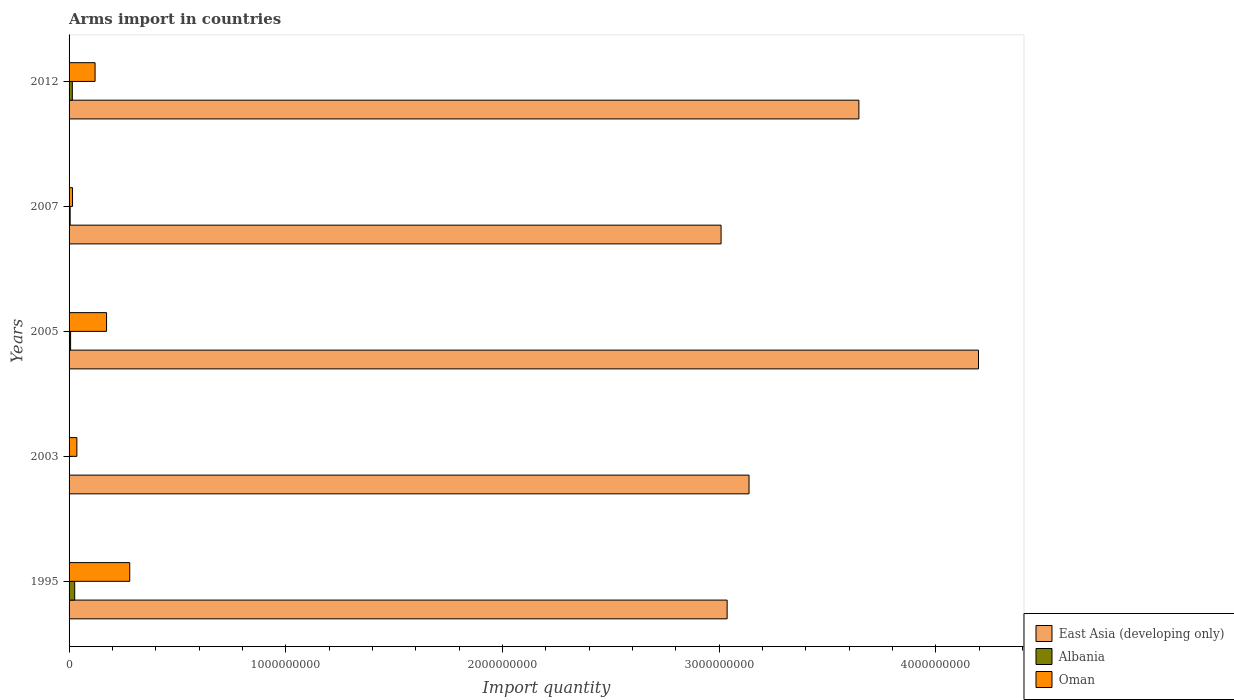How many groups of bars are there?
Provide a succinct answer. 5. Are the number of bars on each tick of the Y-axis equal?
Your answer should be compact. Yes. In how many cases, is the number of bars for a given year not equal to the number of legend labels?
Offer a very short reply. 0. What is the total arms import in Oman in 2003?
Offer a terse response. 3.60e+07. Across all years, what is the maximum total arms import in East Asia (developing only)?
Offer a very short reply. 4.20e+09. Across all years, what is the minimum total arms import in Oman?
Make the answer very short. 1.60e+07. In which year was the total arms import in Oman maximum?
Provide a short and direct response. 1995. In which year was the total arms import in Albania minimum?
Your answer should be compact. 2003. What is the total total arms import in Oman in the graph?
Keep it short and to the point. 6.25e+08. What is the difference between the total arms import in Oman in 1995 and that in 2003?
Provide a short and direct response. 2.44e+08. What is the difference between the total arms import in Oman in 2005 and the total arms import in East Asia (developing only) in 2003?
Your response must be concise. -2.96e+09. What is the average total arms import in East Asia (developing only) per year?
Provide a succinct answer. 3.41e+09. In the year 2012, what is the difference between the total arms import in East Asia (developing only) and total arms import in Albania?
Offer a very short reply. 3.63e+09. In how many years, is the total arms import in Albania greater than 1400000000 ?
Ensure brevity in your answer.  0. What is the ratio of the total arms import in East Asia (developing only) in 1995 to that in 2012?
Keep it short and to the point. 0.83. Is the total arms import in East Asia (developing only) in 2003 less than that in 2005?
Your response must be concise. Yes. Is the difference between the total arms import in East Asia (developing only) in 1995 and 2007 greater than the difference between the total arms import in Albania in 1995 and 2007?
Your answer should be very brief. Yes. What is the difference between the highest and the second highest total arms import in Albania?
Keep it short and to the point. 1.10e+07. What is the difference between the highest and the lowest total arms import in Oman?
Give a very brief answer. 2.64e+08. In how many years, is the total arms import in East Asia (developing only) greater than the average total arms import in East Asia (developing only) taken over all years?
Ensure brevity in your answer.  2. Is the sum of the total arms import in East Asia (developing only) in 1995 and 2005 greater than the maximum total arms import in Albania across all years?
Your answer should be very brief. Yes. What does the 2nd bar from the top in 1995 represents?
Keep it short and to the point. Albania. What does the 3rd bar from the bottom in 1995 represents?
Your answer should be compact. Oman. Is it the case that in every year, the sum of the total arms import in East Asia (developing only) and total arms import in Oman is greater than the total arms import in Albania?
Your answer should be very brief. Yes. How many bars are there?
Your answer should be very brief. 15. Are all the bars in the graph horizontal?
Make the answer very short. Yes. Does the graph contain any zero values?
Make the answer very short. No. Does the graph contain grids?
Your answer should be compact. No. Where does the legend appear in the graph?
Provide a short and direct response. Bottom right. What is the title of the graph?
Offer a terse response. Arms import in countries. What is the label or title of the X-axis?
Give a very brief answer. Import quantity. What is the Import quantity in East Asia (developing only) in 1995?
Ensure brevity in your answer.  3.04e+09. What is the Import quantity of Albania in 1995?
Offer a terse response. 2.60e+07. What is the Import quantity in Oman in 1995?
Your response must be concise. 2.80e+08. What is the Import quantity of East Asia (developing only) in 2003?
Keep it short and to the point. 3.14e+09. What is the Import quantity of Oman in 2003?
Provide a short and direct response. 3.60e+07. What is the Import quantity in East Asia (developing only) in 2005?
Offer a very short reply. 4.20e+09. What is the Import quantity of Albania in 2005?
Provide a short and direct response. 7.00e+06. What is the Import quantity of Oman in 2005?
Make the answer very short. 1.73e+08. What is the Import quantity in East Asia (developing only) in 2007?
Keep it short and to the point. 3.01e+09. What is the Import quantity of Albania in 2007?
Your answer should be very brief. 5.00e+06. What is the Import quantity in Oman in 2007?
Offer a terse response. 1.60e+07. What is the Import quantity in East Asia (developing only) in 2012?
Ensure brevity in your answer.  3.64e+09. What is the Import quantity in Albania in 2012?
Your answer should be very brief. 1.50e+07. What is the Import quantity of Oman in 2012?
Give a very brief answer. 1.20e+08. Across all years, what is the maximum Import quantity in East Asia (developing only)?
Provide a short and direct response. 4.20e+09. Across all years, what is the maximum Import quantity of Albania?
Ensure brevity in your answer.  2.60e+07. Across all years, what is the maximum Import quantity of Oman?
Offer a very short reply. 2.80e+08. Across all years, what is the minimum Import quantity of East Asia (developing only)?
Your answer should be compact. 3.01e+09. Across all years, what is the minimum Import quantity of Oman?
Your answer should be very brief. 1.60e+07. What is the total Import quantity in East Asia (developing only) in the graph?
Make the answer very short. 1.70e+1. What is the total Import quantity in Albania in the graph?
Offer a very short reply. 5.50e+07. What is the total Import quantity in Oman in the graph?
Provide a succinct answer. 6.25e+08. What is the difference between the Import quantity in East Asia (developing only) in 1995 and that in 2003?
Keep it short and to the point. -1.01e+08. What is the difference between the Import quantity of Albania in 1995 and that in 2003?
Ensure brevity in your answer.  2.40e+07. What is the difference between the Import quantity of Oman in 1995 and that in 2003?
Ensure brevity in your answer.  2.44e+08. What is the difference between the Import quantity in East Asia (developing only) in 1995 and that in 2005?
Give a very brief answer. -1.16e+09. What is the difference between the Import quantity in Albania in 1995 and that in 2005?
Provide a succinct answer. 1.90e+07. What is the difference between the Import quantity of Oman in 1995 and that in 2005?
Provide a short and direct response. 1.07e+08. What is the difference between the Import quantity in East Asia (developing only) in 1995 and that in 2007?
Keep it short and to the point. 2.80e+07. What is the difference between the Import quantity of Albania in 1995 and that in 2007?
Ensure brevity in your answer.  2.10e+07. What is the difference between the Import quantity of Oman in 1995 and that in 2007?
Your answer should be compact. 2.64e+08. What is the difference between the Import quantity in East Asia (developing only) in 1995 and that in 2012?
Make the answer very short. -6.08e+08. What is the difference between the Import quantity in Albania in 1995 and that in 2012?
Your answer should be very brief. 1.10e+07. What is the difference between the Import quantity of Oman in 1995 and that in 2012?
Give a very brief answer. 1.60e+08. What is the difference between the Import quantity in East Asia (developing only) in 2003 and that in 2005?
Your response must be concise. -1.06e+09. What is the difference between the Import quantity of Albania in 2003 and that in 2005?
Offer a very short reply. -5.00e+06. What is the difference between the Import quantity of Oman in 2003 and that in 2005?
Provide a succinct answer. -1.37e+08. What is the difference between the Import quantity in East Asia (developing only) in 2003 and that in 2007?
Offer a very short reply. 1.29e+08. What is the difference between the Import quantity in Albania in 2003 and that in 2007?
Ensure brevity in your answer.  -3.00e+06. What is the difference between the Import quantity of Oman in 2003 and that in 2007?
Give a very brief answer. 2.00e+07. What is the difference between the Import quantity in East Asia (developing only) in 2003 and that in 2012?
Give a very brief answer. -5.07e+08. What is the difference between the Import quantity in Albania in 2003 and that in 2012?
Provide a succinct answer. -1.30e+07. What is the difference between the Import quantity in Oman in 2003 and that in 2012?
Provide a succinct answer. -8.40e+07. What is the difference between the Import quantity in East Asia (developing only) in 2005 and that in 2007?
Ensure brevity in your answer.  1.19e+09. What is the difference between the Import quantity of Albania in 2005 and that in 2007?
Ensure brevity in your answer.  2.00e+06. What is the difference between the Import quantity of Oman in 2005 and that in 2007?
Provide a short and direct response. 1.57e+08. What is the difference between the Import quantity of East Asia (developing only) in 2005 and that in 2012?
Give a very brief answer. 5.52e+08. What is the difference between the Import quantity of Albania in 2005 and that in 2012?
Keep it short and to the point. -8.00e+06. What is the difference between the Import quantity of Oman in 2005 and that in 2012?
Make the answer very short. 5.30e+07. What is the difference between the Import quantity in East Asia (developing only) in 2007 and that in 2012?
Ensure brevity in your answer.  -6.36e+08. What is the difference between the Import quantity in Albania in 2007 and that in 2012?
Provide a short and direct response. -1.00e+07. What is the difference between the Import quantity of Oman in 2007 and that in 2012?
Offer a very short reply. -1.04e+08. What is the difference between the Import quantity in East Asia (developing only) in 1995 and the Import quantity in Albania in 2003?
Your answer should be very brief. 3.04e+09. What is the difference between the Import quantity of East Asia (developing only) in 1995 and the Import quantity of Oman in 2003?
Ensure brevity in your answer.  3.00e+09. What is the difference between the Import quantity in Albania in 1995 and the Import quantity in Oman in 2003?
Offer a terse response. -1.00e+07. What is the difference between the Import quantity of East Asia (developing only) in 1995 and the Import quantity of Albania in 2005?
Keep it short and to the point. 3.03e+09. What is the difference between the Import quantity in East Asia (developing only) in 1995 and the Import quantity in Oman in 2005?
Offer a very short reply. 2.86e+09. What is the difference between the Import quantity of Albania in 1995 and the Import quantity of Oman in 2005?
Ensure brevity in your answer.  -1.47e+08. What is the difference between the Import quantity of East Asia (developing only) in 1995 and the Import quantity of Albania in 2007?
Make the answer very short. 3.03e+09. What is the difference between the Import quantity of East Asia (developing only) in 1995 and the Import quantity of Oman in 2007?
Make the answer very short. 3.02e+09. What is the difference between the Import quantity of East Asia (developing only) in 1995 and the Import quantity of Albania in 2012?
Provide a succinct answer. 3.02e+09. What is the difference between the Import quantity in East Asia (developing only) in 1995 and the Import quantity in Oman in 2012?
Provide a short and direct response. 2.92e+09. What is the difference between the Import quantity in Albania in 1995 and the Import quantity in Oman in 2012?
Keep it short and to the point. -9.40e+07. What is the difference between the Import quantity of East Asia (developing only) in 2003 and the Import quantity of Albania in 2005?
Provide a succinct answer. 3.13e+09. What is the difference between the Import quantity of East Asia (developing only) in 2003 and the Import quantity of Oman in 2005?
Give a very brief answer. 2.96e+09. What is the difference between the Import quantity in Albania in 2003 and the Import quantity in Oman in 2005?
Make the answer very short. -1.71e+08. What is the difference between the Import quantity of East Asia (developing only) in 2003 and the Import quantity of Albania in 2007?
Offer a very short reply. 3.13e+09. What is the difference between the Import quantity of East Asia (developing only) in 2003 and the Import quantity of Oman in 2007?
Your response must be concise. 3.12e+09. What is the difference between the Import quantity of Albania in 2003 and the Import quantity of Oman in 2007?
Provide a short and direct response. -1.40e+07. What is the difference between the Import quantity in East Asia (developing only) in 2003 and the Import quantity in Albania in 2012?
Your answer should be compact. 3.12e+09. What is the difference between the Import quantity of East Asia (developing only) in 2003 and the Import quantity of Oman in 2012?
Provide a succinct answer. 3.02e+09. What is the difference between the Import quantity of Albania in 2003 and the Import quantity of Oman in 2012?
Ensure brevity in your answer.  -1.18e+08. What is the difference between the Import quantity in East Asia (developing only) in 2005 and the Import quantity in Albania in 2007?
Keep it short and to the point. 4.19e+09. What is the difference between the Import quantity in East Asia (developing only) in 2005 and the Import quantity in Oman in 2007?
Your answer should be compact. 4.18e+09. What is the difference between the Import quantity of Albania in 2005 and the Import quantity of Oman in 2007?
Ensure brevity in your answer.  -9.00e+06. What is the difference between the Import quantity of East Asia (developing only) in 2005 and the Import quantity of Albania in 2012?
Keep it short and to the point. 4.18e+09. What is the difference between the Import quantity of East Asia (developing only) in 2005 and the Import quantity of Oman in 2012?
Your answer should be compact. 4.08e+09. What is the difference between the Import quantity in Albania in 2005 and the Import quantity in Oman in 2012?
Your answer should be very brief. -1.13e+08. What is the difference between the Import quantity of East Asia (developing only) in 2007 and the Import quantity of Albania in 2012?
Your answer should be very brief. 2.99e+09. What is the difference between the Import quantity in East Asia (developing only) in 2007 and the Import quantity in Oman in 2012?
Keep it short and to the point. 2.89e+09. What is the difference between the Import quantity in Albania in 2007 and the Import quantity in Oman in 2012?
Ensure brevity in your answer.  -1.15e+08. What is the average Import quantity in East Asia (developing only) per year?
Offer a terse response. 3.41e+09. What is the average Import quantity of Albania per year?
Keep it short and to the point. 1.10e+07. What is the average Import quantity of Oman per year?
Your answer should be compact. 1.25e+08. In the year 1995, what is the difference between the Import quantity in East Asia (developing only) and Import quantity in Albania?
Keep it short and to the point. 3.01e+09. In the year 1995, what is the difference between the Import quantity of East Asia (developing only) and Import quantity of Oman?
Your response must be concise. 2.76e+09. In the year 1995, what is the difference between the Import quantity in Albania and Import quantity in Oman?
Provide a short and direct response. -2.54e+08. In the year 2003, what is the difference between the Import quantity in East Asia (developing only) and Import quantity in Albania?
Your answer should be compact. 3.14e+09. In the year 2003, what is the difference between the Import quantity of East Asia (developing only) and Import quantity of Oman?
Give a very brief answer. 3.10e+09. In the year 2003, what is the difference between the Import quantity of Albania and Import quantity of Oman?
Your answer should be very brief. -3.40e+07. In the year 2005, what is the difference between the Import quantity of East Asia (developing only) and Import quantity of Albania?
Give a very brief answer. 4.19e+09. In the year 2005, what is the difference between the Import quantity in East Asia (developing only) and Import quantity in Oman?
Your answer should be compact. 4.02e+09. In the year 2005, what is the difference between the Import quantity of Albania and Import quantity of Oman?
Keep it short and to the point. -1.66e+08. In the year 2007, what is the difference between the Import quantity in East Asia (developing only) and Import quantity in Albania?
Give a very brief answer. 3.00e+09. In the year 2007, what is the difference between the Import quantity of East Asia (developing only) and Import quantity of Oman?
Offer a terse response. 2.99e+09. In the year 2007, what is the difference between the Import quantity of Albania and Import quantity of Oman?
Offer a very short reply. -1.10e+07. In the year 2012, what is the difference between the Import quantity in East Asia (developing only) and Import quantity in Albania?
Ensure brevity in your answer.  3.63e+09. In the year 2012, what is the difference between the Import quantity in East Asia (developing only) and Import quantity in Oman?
Ensure brevity in your answer.  3.52e+09. In the year 2012, what is the difference between the Import quantity of Albania and Import quantity of Oman?
Provide a succinct answer. -1.05e+08. What is the ratio of the Import quantity in East Asia (developing only) in 1995 to that in 2003?
Give a very brief answer. 0.97. What is the ratio of the Import quantity of Albania in 1995 to that in 2003?
Your answer should be very brief. 13. What is the ratio of the Import quantity of Oman in 1995 to that in 2003?
Your response must be concise. 7.78. What is the ratio of the Import quantity in East Asia (developing only) in 1995 to that in 2005?
Keep it short and to the point. 0.72. What is the ratio of the Import quantity in Albania in 1995 to that in 2005?
Your answer should be compact. 3.71. What is the ratio of the Import quantity of Oman in 1995 to that in 2005?
Offer a terse response. 1.62. What is the ratio of the Import quantity in East Asia (developing only) in 1995 to that in 2007?
Ensure brevity in your answer.  1.01. What is the ratio of the Import quantity of Oman in 1995 to that in 2007?
Provide a succinct answer. 17.5. What is the ratio of the Import quantity of East Asia (developing only) in 1995 to that in 2012?
Ensure brevity in your answer.  0.83. What is the ratio of the Import quantity in Albania in 1995 to that in 2012?
Your answer should be compact. 1.73. What is the ratio of the Import quantity of Oman in 1995 to that in 2012?
Your response must be concise. 2.33. What is the ratio of the Import quantity in East Asia (developing only) in 2003 to that in 2005?
Provide a succinct answer. 0.75. What is the ratio of the Import quantity of Albania in 2003 to that in 2005?
Give a very brief answer. 0.29. What is the ratio of the Import quantity of Oman in 2003 to that in 2005?
Your response must be concise. 0.21. What is the ratio of the Import quantity of East Asia (developing only) in 2003 to that in 2007?
Your response must be concise. 1.04. What is the ratio of the Import quantity in Albania in 2003 to that in 2007?
Offer a terse response. 0.4. What is the ratio of the Import quantity of Oman in 2003 to that in 2007?
Your answer should be compact. 2.25. What is the ratio of the Import quantity in East Asia (developing only) in 2003 to that in 2012?
Ensure brevity in your answer.  0.86. What is the ratio of the Import quantity of Albania in 2003 to that in 2012?
Give a very brief answer. 0.13. What is the ratio of the Import quantity in Oman in 2003 to that in 2012?
Give a very brief answer. 0.3. What is the ratio of the Import quantity of East Asia (developing only) in 2005 to that in 2007?
Offer a terse response. 1.39. What is the ratio of the Import quantity in Oman in 2005 to that in 2007?
Offer a very short reply. 10.81. What is the ratio of the Import quantity of East Asia (developing only) in 2005 to that in 2012?
Give a very brief answer. 1.15. What is the ratio of the Import quantity of Albania in 2005 to that in 2012?
Ensure brevity in your answer.  0.47. What is the ratio of the Import quantity of Oman in 2005 to that in 2012?
Ensure brevity in your answer.  1.44. What is the ratio of the Import quantity of East Asia (developing only) in 2007 to that in 2012?
Give a very brief answer. 0.83. What is the ratio of the Import quantity of Albania in 2007 to that in 2012?
Your answer should be compact. 0.33. What is the ratio of the Import quantity in Oman in 2007 to that in 2012?
Ensure brevity in your answer.  0.13. What is the difference between the highest and the second highest Import quantity in East Asia (developing only)?
Your answer should be compact. 5.52e+08. What is the difference between the highest and the second highest Import quantity of Albania?
Give a very brief answer. 1.10e+07. What is the difference between the highest and the second highest Import quantity in Oman?
Provide a short and direct response. 1.07e+08. What is the difference between the highest and the lowest Import quantity in East Asia (developing only)?
Your answer should be compact. 1.19e+09. What is the difference between the highest and the lowest Import quantity of Albania?
Offer a terse response. 2.40e+07. What is the difference between the highest and the lowest Import quantity of Oman?
Provide a succinct answer. 2.64e+08. 